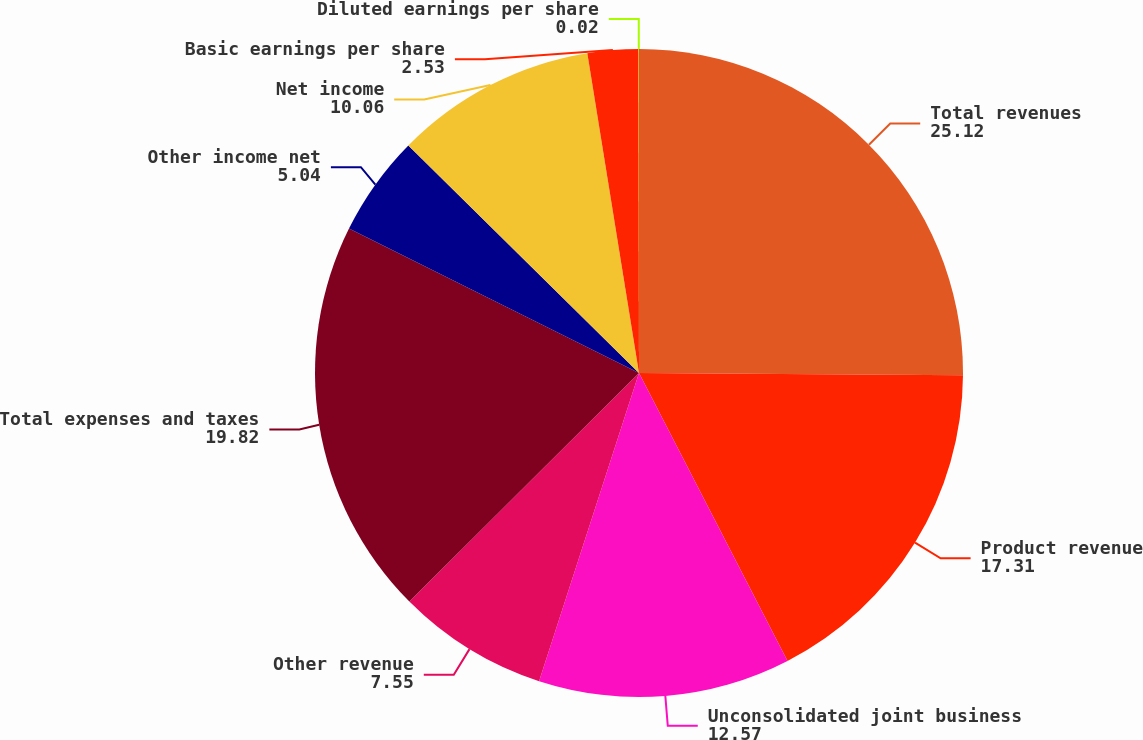Convert chart to OTSL. <chart><loc_0><loc_0><loc_500><loc_500><pie_chart><fcel>Total revenues<fcel>Product revenue<fcel>Unconsolidated joint business<fcel>Other revenue<fcel>Total expenses and taxes<fcel>Other income net<fcel>Net income<fcel>Basic earnings per share<fcel>Diluted earnings per share<nl><fcel>25.12%<fcel>17.31%<fcel>12.57%<fcel>7.55%<fcel>19.82%<fcel>5.04%<fcel>10.06%<fcel>2.53%<fcel>0.02%<nl></chart> 